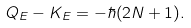Convert formula to latex. <formula><loc_0><loc_0><loc_500><loc_500>Q _ { E } - K _ { E } = - \hbar { ( } 2 N + 1 ) .</formula> 